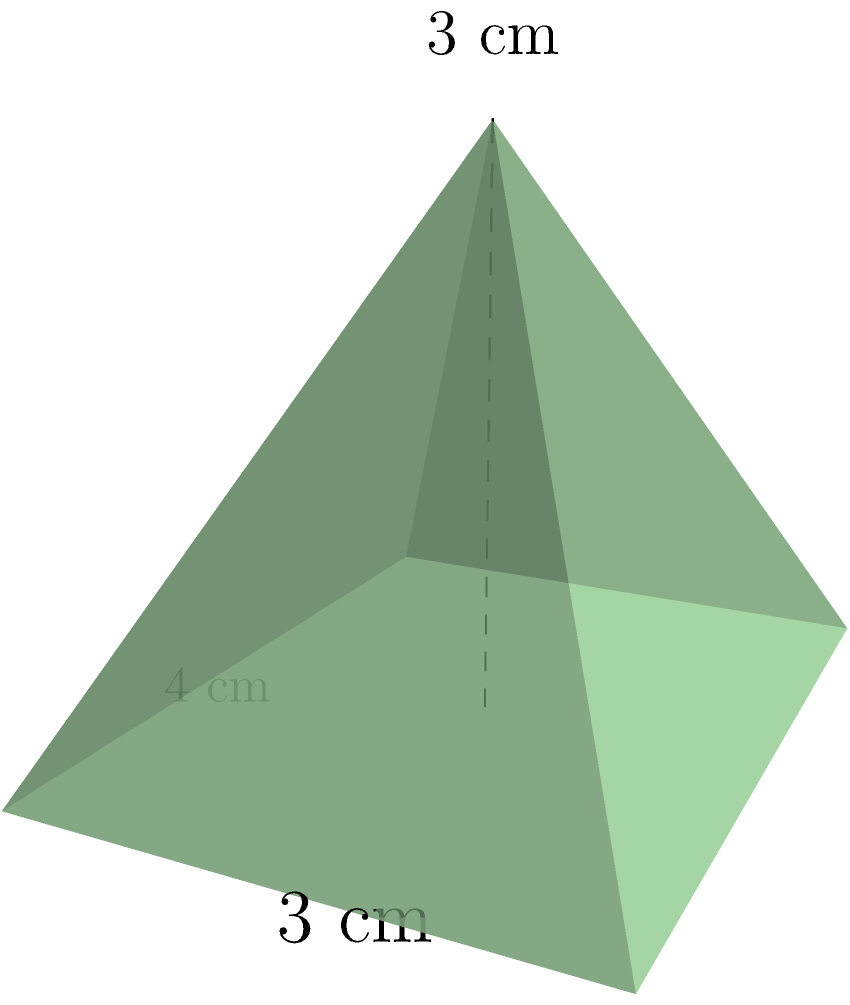A new organic snack company wants to package their product in a unique pyramid-shaped container. As the PR professional managing the diet program creator's image, you need to verify the product details. The base of the pyramid-shaped package is a rectangle measuring 4 cm by 3 cm, and the height of the pyramid is 3 cm. What is the volume of this package in cubic centimeters? To find the volume of a pyramid, we use the formula:

$$V = \frac{1}{3} \times B \times h$$

Where:
$V$ = volume
$B$ = area of the base
$h$ = height of the pyramid

Step 1: Calculate the area of the base (B)
The base is a rectangle, so:
$$B = \text{length} \times \text{width} = 4 \text{ cm} \times 3 \text{ cm} = 12 \text{ cm}^2$$

Step 2: Apply the volume formula
$$V = \frac{1}{3} \times B \times h$$
$$V = \frac{1}{3} \times 12 \text{ cm}^2 \times 3 \text{ cm}$$
$$V = 4 \times 3 \text{ cm}^3 = 12 \text{ cm}^3$$

Therefore, the volume of the pyramid-shaped package is 12 cubic centimeters.
Answer: 12 cm³ 